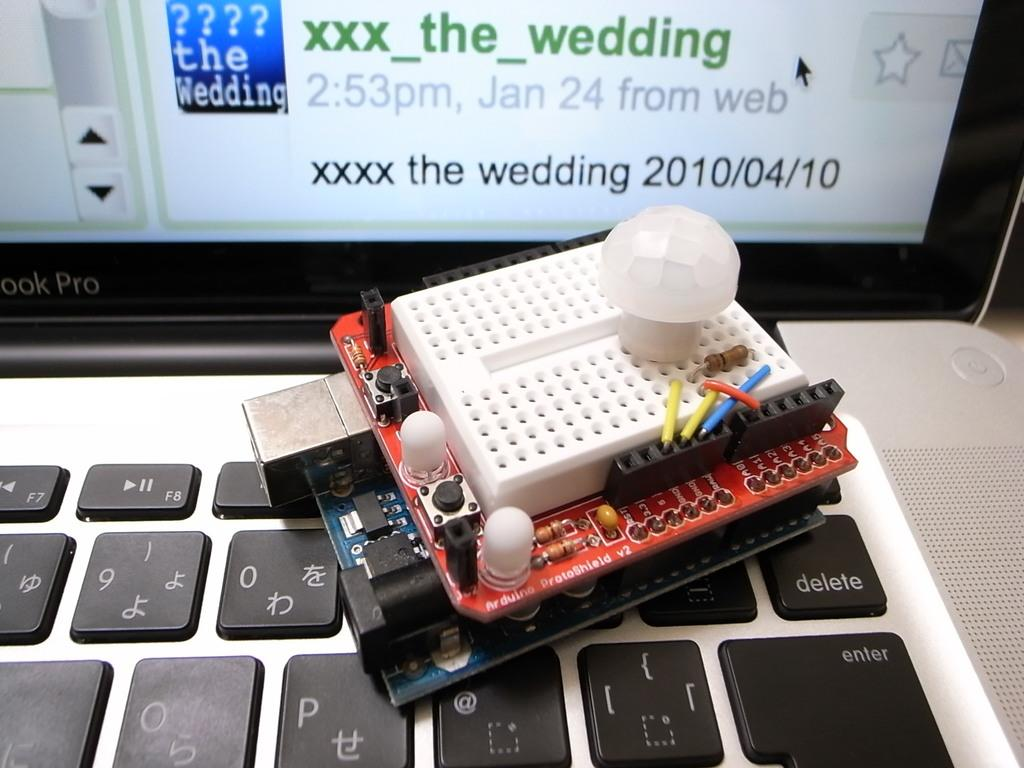<image>
Write a terse but informative summary of the picture. A circuit board sits on a keyboard in front of a screen promotiong the wedding on April 10, 2010. 